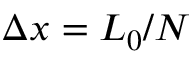Convert formula to latex. <formula><loc_0><loc_0><loc_500><loc_500>\Delta x = L _ { 0 } / N</formula> 